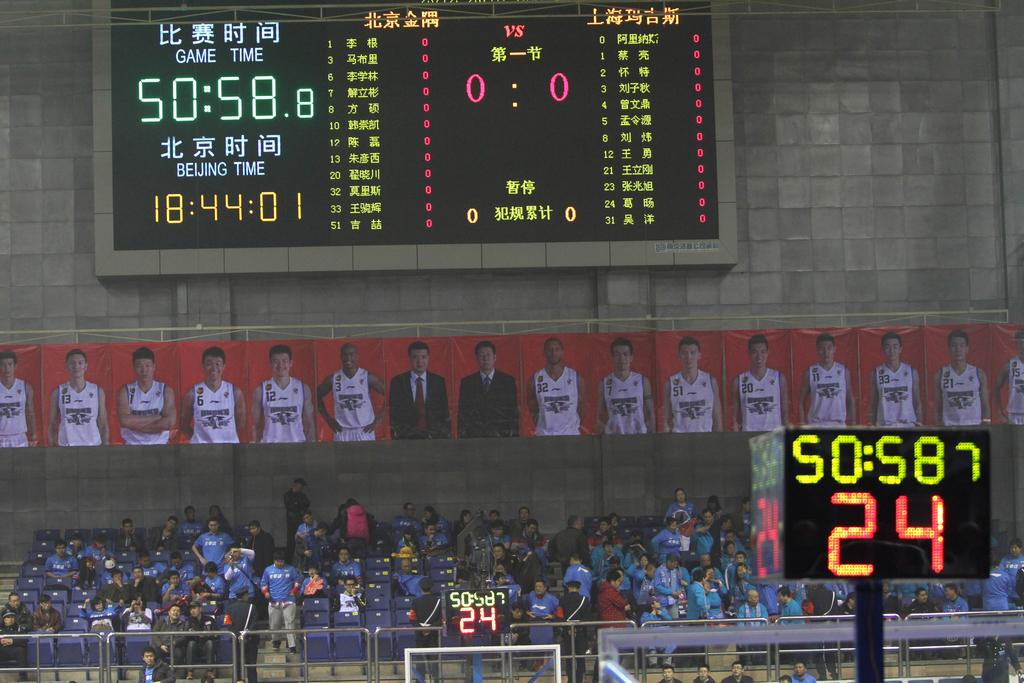Provide a one-sentence caption for the provided image. A basketball game in China is underway and the clock says 50:58. 